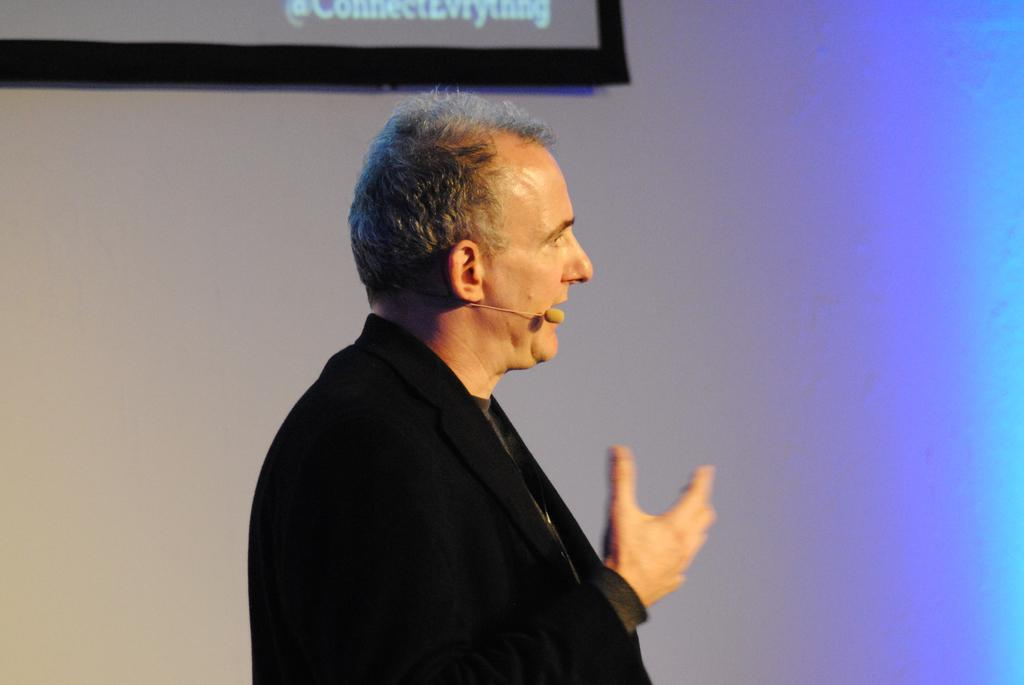Who is the main subject in the image? There is a person in the center of the image. What is the person wearing? The person is wearing a black color suit. What is the person holding in the image? The person is holding a mic. What can be seen in the background of the image? There is a wall in the background of the image. How many verses can be seen on the person's eye in the image? There are no verses visible on the person's eye in the image. 